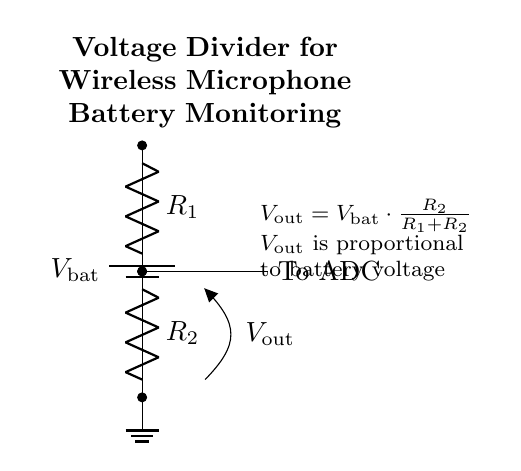What is the purpose of this circuit? The purpose of this circuit is to monitor battery levels in wireless microphones by dividing the battery voltage.
Answer: Battery monitoring What are the main components of this circuit? The main components are a battery and two resistors.
Answer: Battery and resistors What do the resistors R1 and R2 represent? R1 and R2 are resistors that create a voltage divider to scale down the battery voltage for monitoring.
Answer: Voltage divider resistors What is the formula for the output voltage Vout? The formula for Vout is Vout = Vbat * (R2 / (R1 + R2)), indicating how the output voltage relates to the input battery voltage and the resistor values.
Answer: Vout = Vbat * (R2 / (R1 + R2)) How does the output voltage change with different values of R2? If R2 increases while R1 remains constant, Vout increases, indicating that a higher resistor value results in a larger proportion of the battery voltage being measured.
Answer: Vout increases What is the relationship between Vout and Vbat? Vout is a fraction of Vbat, as determined by the resistor values in the voltage divider. This means as Vbat changes, Vout changes proportionally based on the resistor values.
Answer: Vout is proportional to Vbat What would happen if R1 is much smaller than R2? If R1 is much smaller than R2, Vout approaches Vbat, meaning the output voltage would be nearly equal to the battery voltage, providing an inaccurate representation for monitoring.
Answer: Vout approaches Vbat 